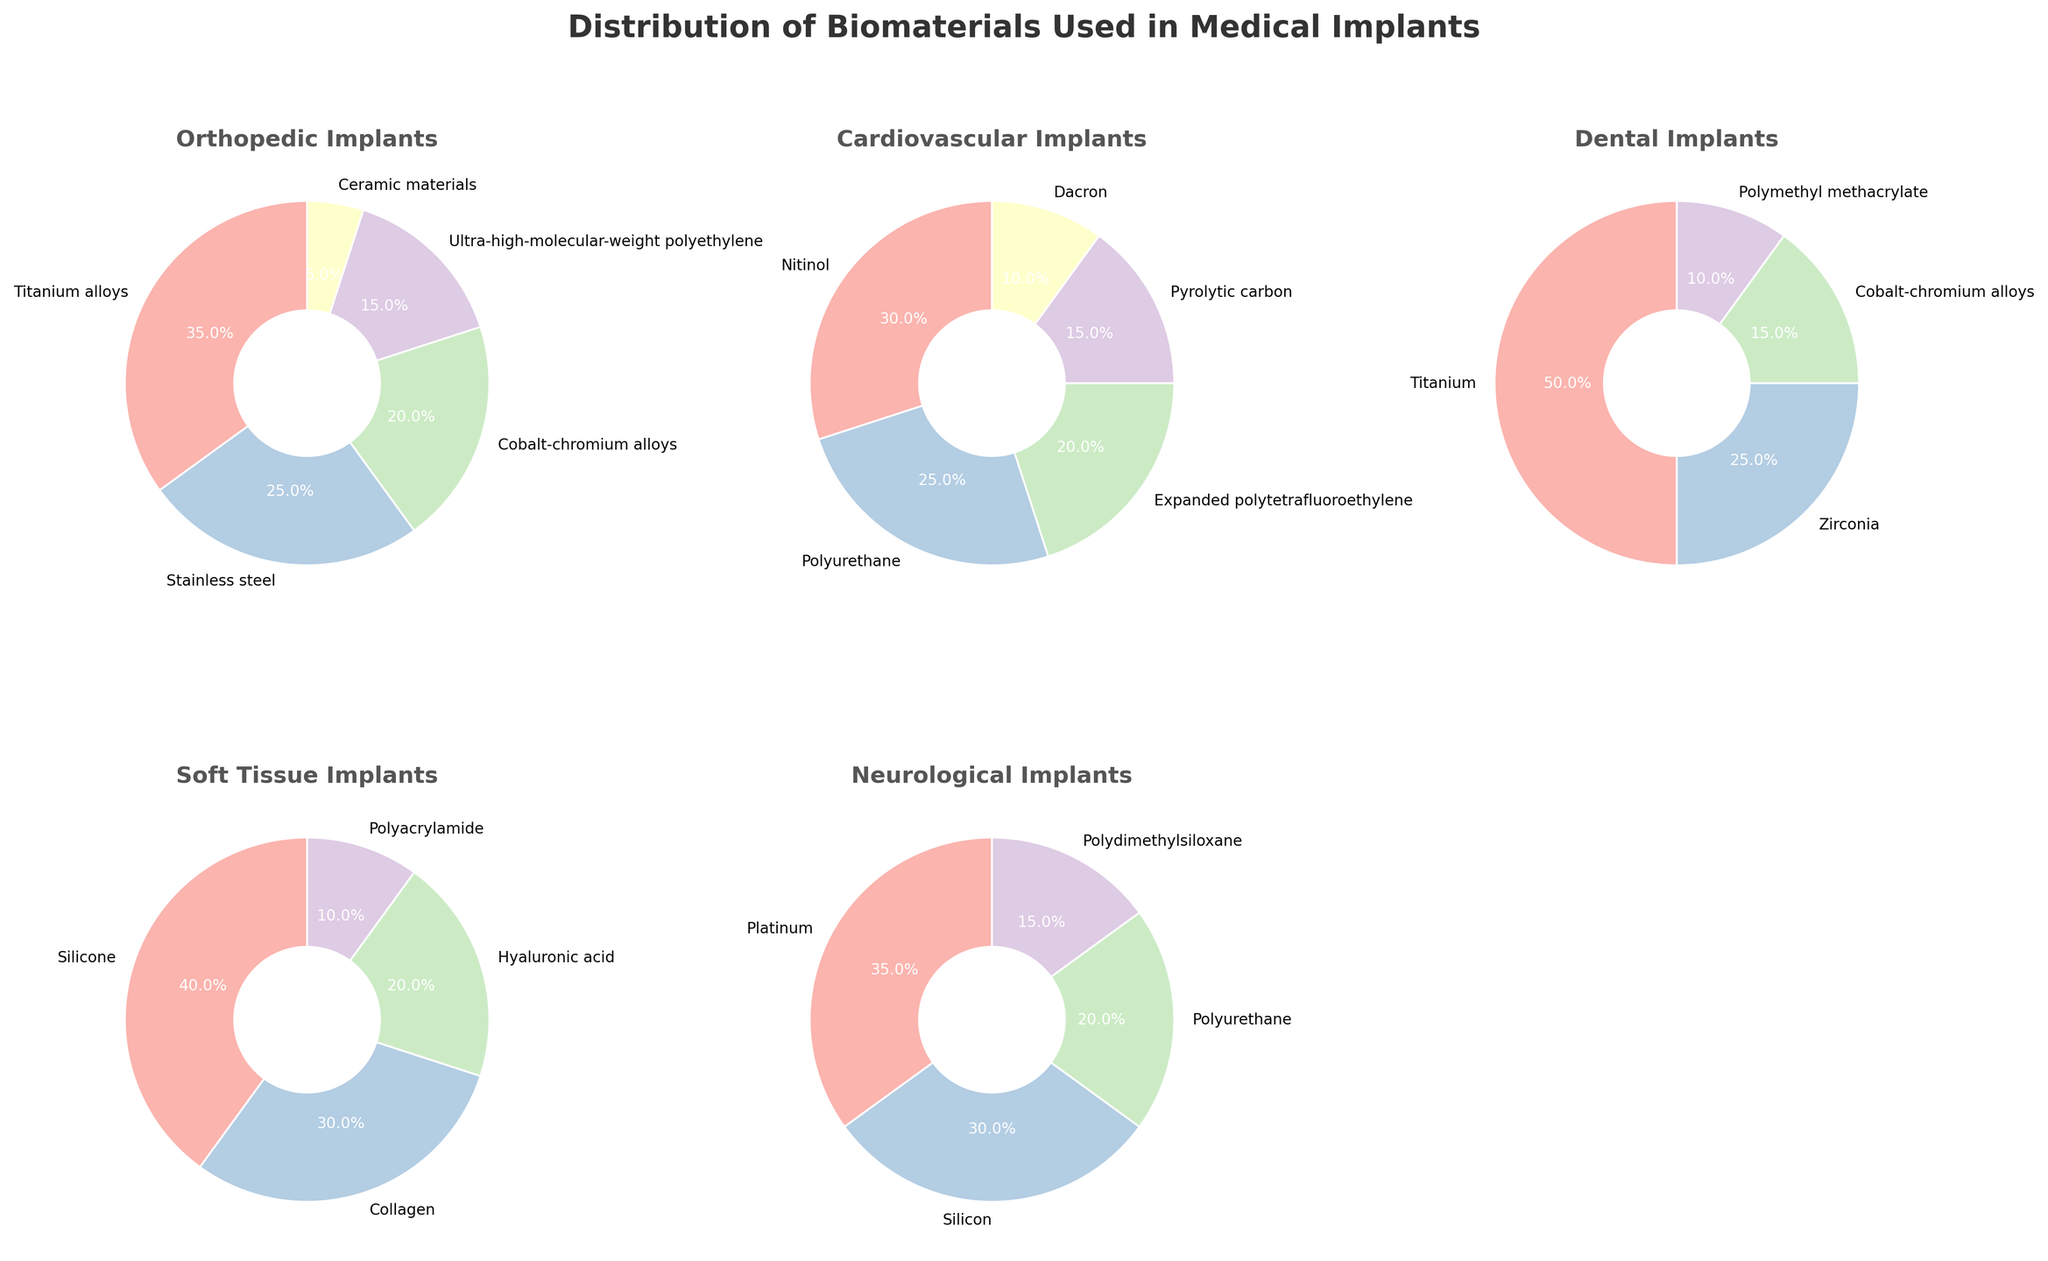What's the most commonly used material in orthopedic implants? By observing the orthopedic implants pie chart, the segment with the largest percentage represents the material most commonly used. Titanium alloys account for 35%, which is the largest segment.
Answer: Titanium alloys What's the combined percentage of silicone and collagen in soft tissue implants? Add the percentages of silicone and collagen from the soft tissue implants pie chart. Silicone is 40% and collagen is 30%. 40 + 30 = 70.
Answer: 70% Which type of medical implant has the highest percentage of a single material, and what is the material? Compare the highest percentage values in each pie chart. Dental implants have the highest percentage with Titanium at 50%.
Answer: Dental implants with Titanium How does the use of polyurethane differ between cardiovascular and neurological implants? Compare the percentage values of polyurethane in both cardiovascular and neurological implants pie charts. Cardiovascular has polyurethane at 25%, while neurological has it at 20%.
Answer: Polyurethane is 5% more in cardiovascular implants than in neurological implants What is the difference between the highest and lowest percentage of materials used in orthopedic implants? Identify the highest and lowest percentages in the orthopedic implants pie chart. The highest is Titanium alloys at 35%, the lowest is Ceramic materials at 5%. The difference is 35 - 5 = 30.
Answer: 30% Which type of medical implant utilizes the most diverse range of materials in terms of quantity? Count the number of different materials listed in each pie chart. Both orthopedic implants and cardiovascular implants have five different materials listed, which is the highest quantity among the given types.
Answer: Orthopedic implants and Cardiovascular implants What's the total percentage of materials other than silicone in soft tissue implants? Subtract the percentage of silicone from the total 100% in the soft tissue implants pie chart. Silicone is 40%, so 100 - 40 = 60.
Answer: 60% Which material is shared between orthopedic and dental implants, and what are their respective percentages? Identify the common materials in both pie charts for orthopedic and dental implants. Cobalt-chromium alloys are present in both. Orthopedic has 20% and dental has 15%.
Answer: Cobalt-chromium alloys with 20% in orthopedic and 15% in dental How does the use of titanium alloys in orthopedic implants compare to titanium in dental implants? Compare the percentage of titanium alloys in orthopedic implants with that of titanium in dental implants. Orthopedic implants have 35% titanium alloys, while dental implants have 50% titanium. Titanium is used more in dental implants by 50 - 35 = 15%.
Answer: 15% more in dental implants What's the combined percentage of polymer-based materials in neurological implants? Sum the percentages of polymer-based materials in neurological implants. Polyurethane is 20% and Polydimethylsiloxane is 15%. So, 20 + 15 = 35.
Answer: 35% 